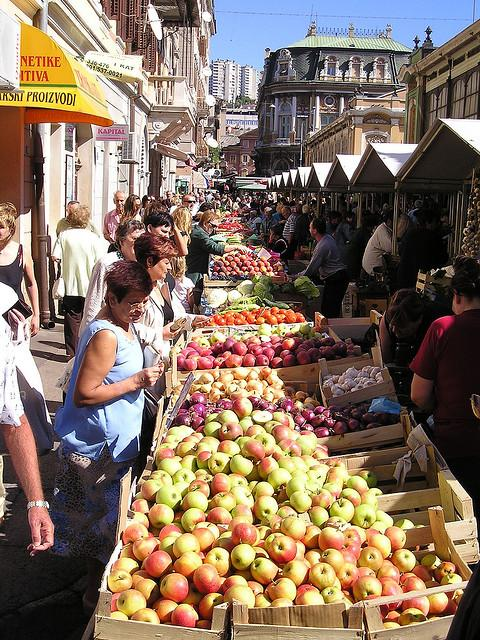Where does a shopper look to see how much a certain fruit costs? Please explain your reasoning. cardboard sign. The prices are on the boxes 